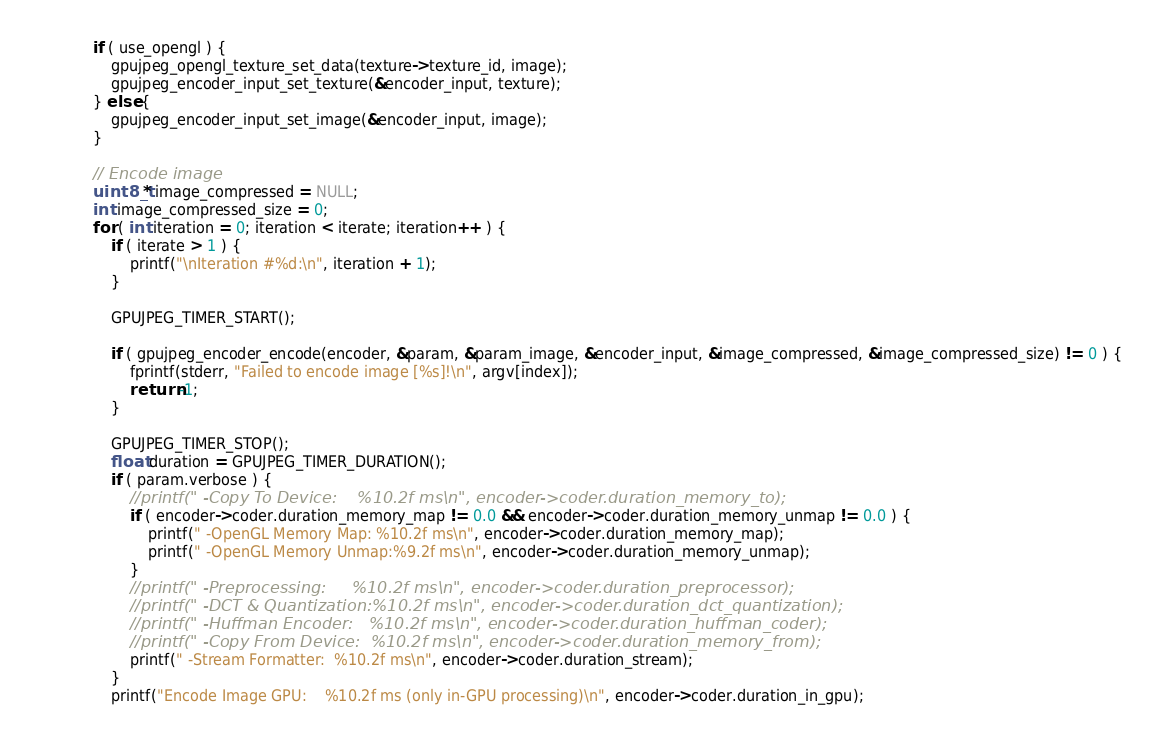<code> <loc_0><loc_0><loc_500><loc_500><_C_>            if ( use_opengl ) {
                gpujpeg_opengl_texture_set_data(texture->texture_id, image);
                gpujpeg_encoder_input_set_texture(&encoder_input, texture);
            } else {
                gpujpeg_encoder_input_set_image(&encoder_input, image);
            }

            // Encode image
            uint8_t* image_compressed = NULL;
            int image_compressed_size = 0;
            for ( int iteration = 0; iteration < iterate; iteration++ ) {
                if ( iterate > 1 ) {
                    printf("\nIteration #%d:\n", iteration + 1);
                }

                GPUJPEG_TIMER_START();

                if ( gpujpeg_encoder_encode(encoder, &param, &param_image, &encoder_input, &image_compressed, &image_compressed_size) != 0 ) {
                    fprintf(stderr, "Failed to encode image [%s]!\n", argv[index]);
                    return -1;
                }

                GPUJPEG_TIMER_STOP();
                float duration = GPUJPEG_TIMER_DURATION();
                if ( param.verbose ) {
                    //printf(" -Copy To Device:    %10.2f ms\n", encoder->coder.duration_memory_to);
                    if ( encoder->coder.duration_memory_map != 0.0 && encoder->coder.duration_memory_unmap != 0.0 ) {
                        printf(" -OpenGL Memory Map: %10.2f ms\n", encoder->coder.duration_memory_map);
                        printf(" -OpenGL Memory Unmap:%9.2f ms\n", encoder->coder.duration_memory_unmap);
                    }
                    //printf(" -Preprocessing:     %10.2f ms\n", encoder->coder.duration_preprocessor);
                    //printf(" -DCT & Quantization:%10.2f ms\n", encoder->coder.duration_dct_quantization);
                    //printf(" -Huffman Encoder:   %10.2f ms\n", encoder->coder.duration_huffman_coder);
                    //printf(" -Copy From Device:  %10.2f ms\n", encoder->coder.duration_memory_from);
                    printf(" -Stream Formatter:  %10.2f ms\n", encoder->coder.duration_stream);
                }
                printf("Encode Image GPU:    %10.2f ms (only in-GPU processing)\n", encoder->coder.duration_in_gpu);</code> 